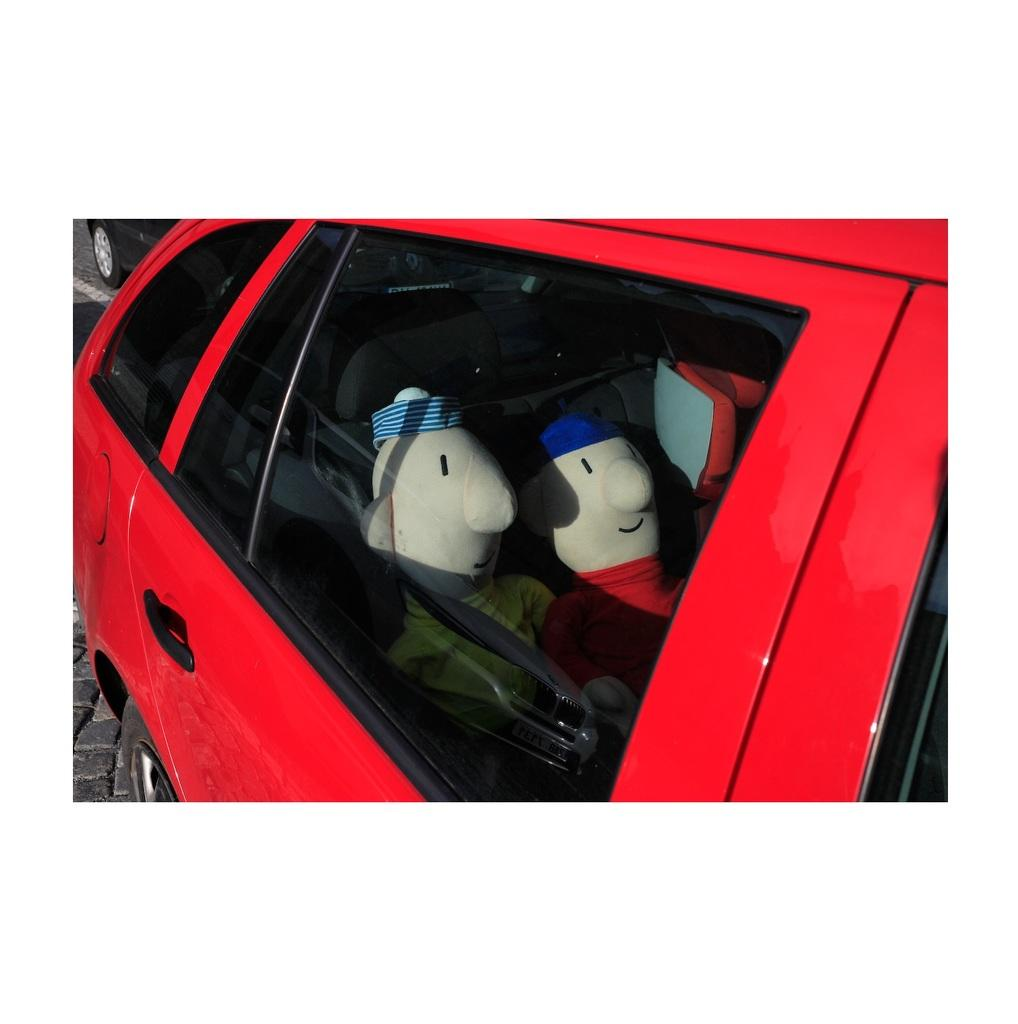What is the main subject of the image? There is a vehicle on a road in the image. Are there any passengers in the vehicle? Yes, there are dolls inside the vehicle. Can you describe the surroundings of the vehicle? There is another vehicle visible in the background on the road. What type of harbor can be seen in the image? There is no harbor present in the image; it features a vehicle on a road with dolls inside and another vehicle in the background. How many icicles are hanging from the vehicle in the image? There are no icicles present in the image. 